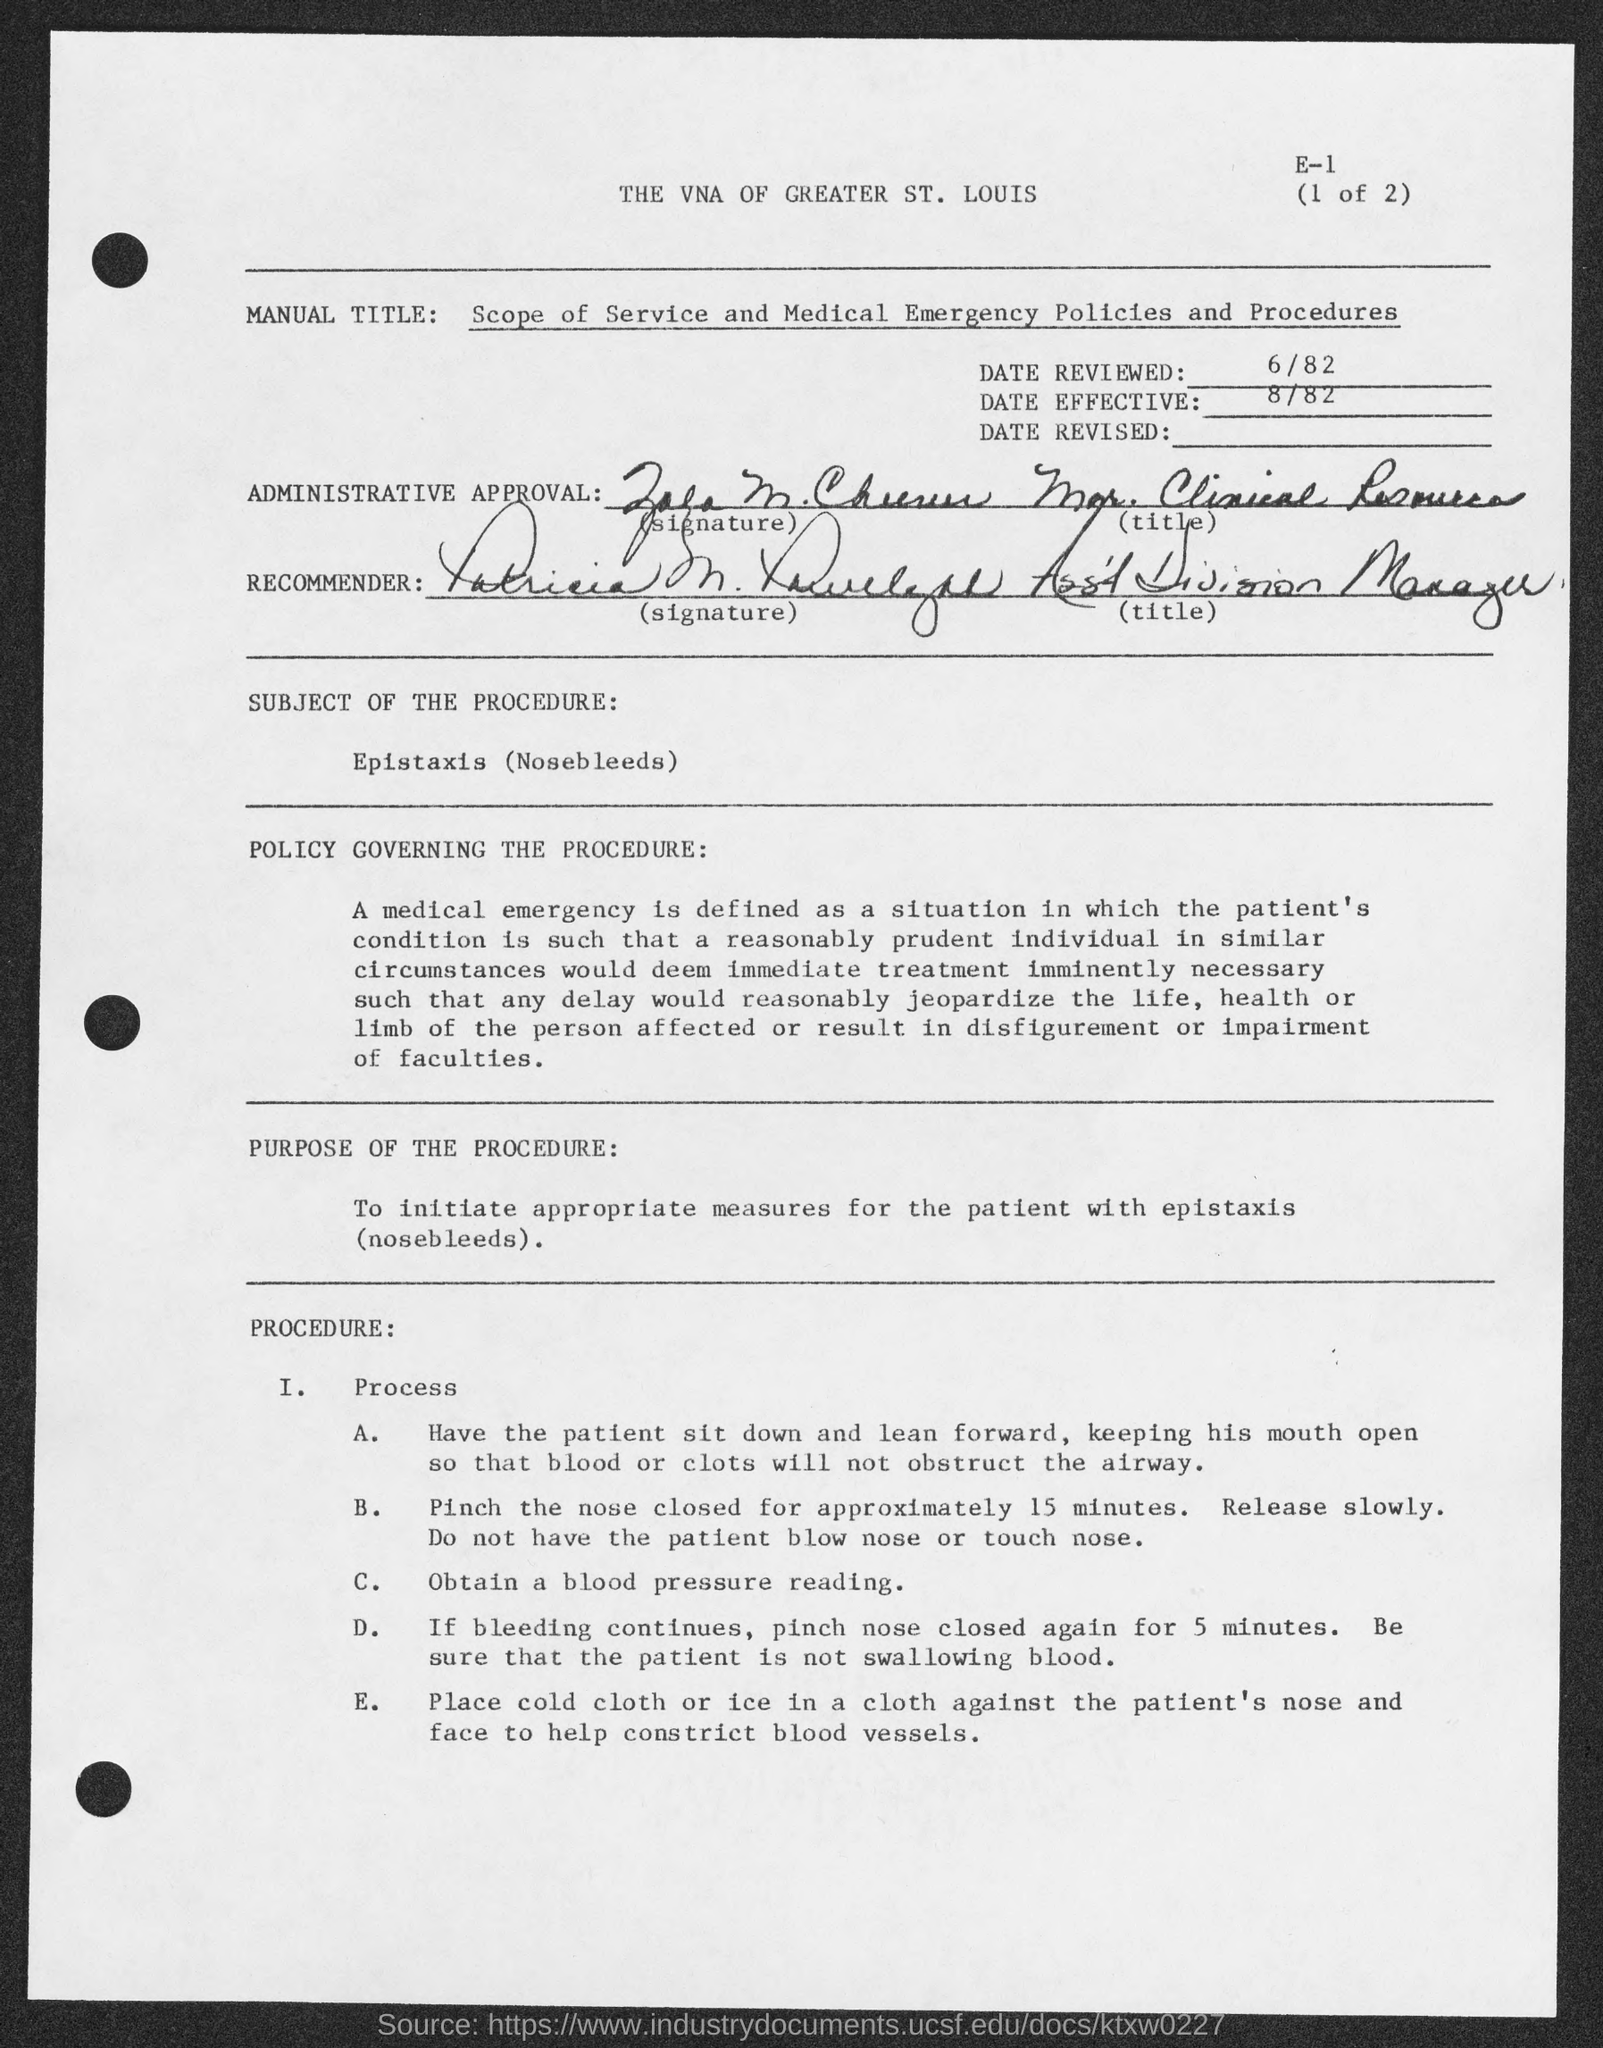Indicate a few pertinent items in this graphic. It is recommended to pinch the nose for approximately 15 minutes. This is effective from August 1982. The procedure referred to as "nosebleeds" is a specific process. The title of the recommender is Assistant Division Manager. 